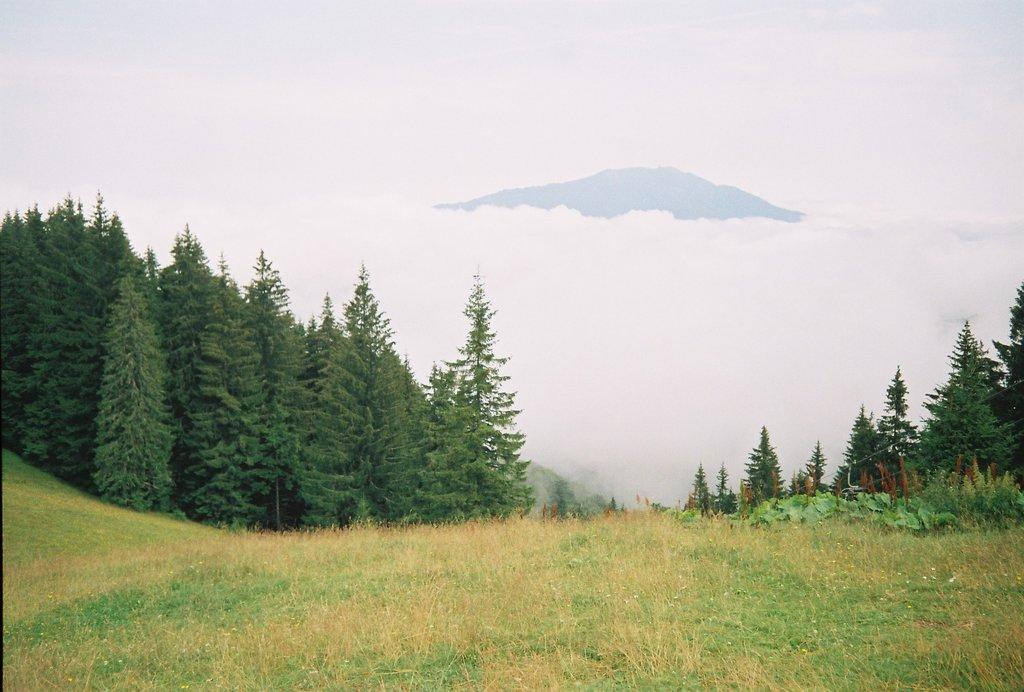What type of vegetation is present in the image? There is grass in the image. What other natural elements can be seen in the image? There are trees in the image. What can be seen in the distance in the image? The sky is visible in the background of the image. How many mittens are hanging on the tree in the image? There are no mittens present in the image; it features grass, trees, and the sky. 